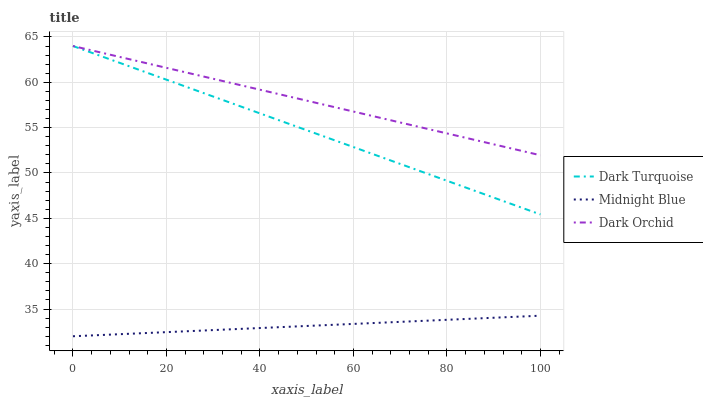Does Midnight Blue have the minimum area under the curve?
Answer yes or no. Yes. Does Dark Orchid have the maximum area under the curve?
Answer yes or no. Yes. Does Dark Orchid have the minimum area under the curve?
Answer yes or no. No. Does Midnight Blue have the maximum area under the curve?
Answer yes or no. No. Is Dark Orchid the smoothest?
Answer yes or no. Yes. Is Dark Turquoise the roughest?
Answer yes or no. Yes. Is Midnight Blue the smoothest?
Answer yes or no. No. Is Midnight Blue the roughest?
Answer yes or no. No. Does Midnight Blue have the lowest value?
Answer yes or no. Yes. Does Dark Orchid have the lowest value?
Answer yes or no. No. Does Dark Orchid have the highest value?
Answer yes or no. Yes. Does Midnight Blue have the highest value?
Answer yes or no. No. Is Midnight Blue less than Dark Orchid?
Answer yes or no. Yes. Is Dark Turquoise greater than Midnight Blue?
Answer yes or no. Yes. Does Dark Orchid intersect Dark Turquoise?
Answer yes or no. Yes. Is Dark Orchid less than Dark Turquoise?
Answer yes or no. No. Is Dark Orchid greater than Dark Turquoise?
Answer yes or no. No. Does Midnight Blue intersect Dark Orchid?
Answer yes or no. No. 